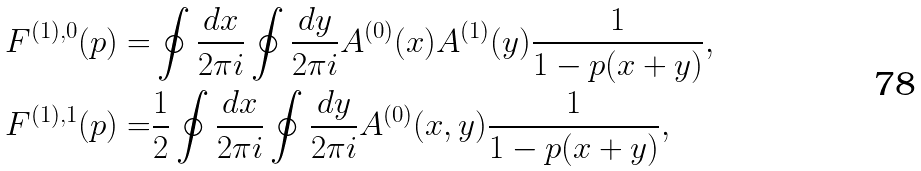Convert formula to latex. <formula><loc_0><loc_0><loc_500><loc_500>F ^ { ( 1 ) , 0 } ( p ) = & \oint \frac { d x } { 2 \pi i } \oint \frac { d y } { 2 \pi i } A ^ { ( 0 ) } ( x ) A ^ { ( 1 ) } ( y ) \frac { 1 } { 1 - p ( x + y ) } , \\ F ^ { ( 1 ) , 1 } ( p ) = & \frac { 1 } { 2 } \oint \frac { d x } { 2 \pi i } \oint \frac { d y } { 2 \pi i } A ^ { ( 0 ) } ( x , y ) \frac { 1 } { 1 - p ( x + y ) } ,</formula> 